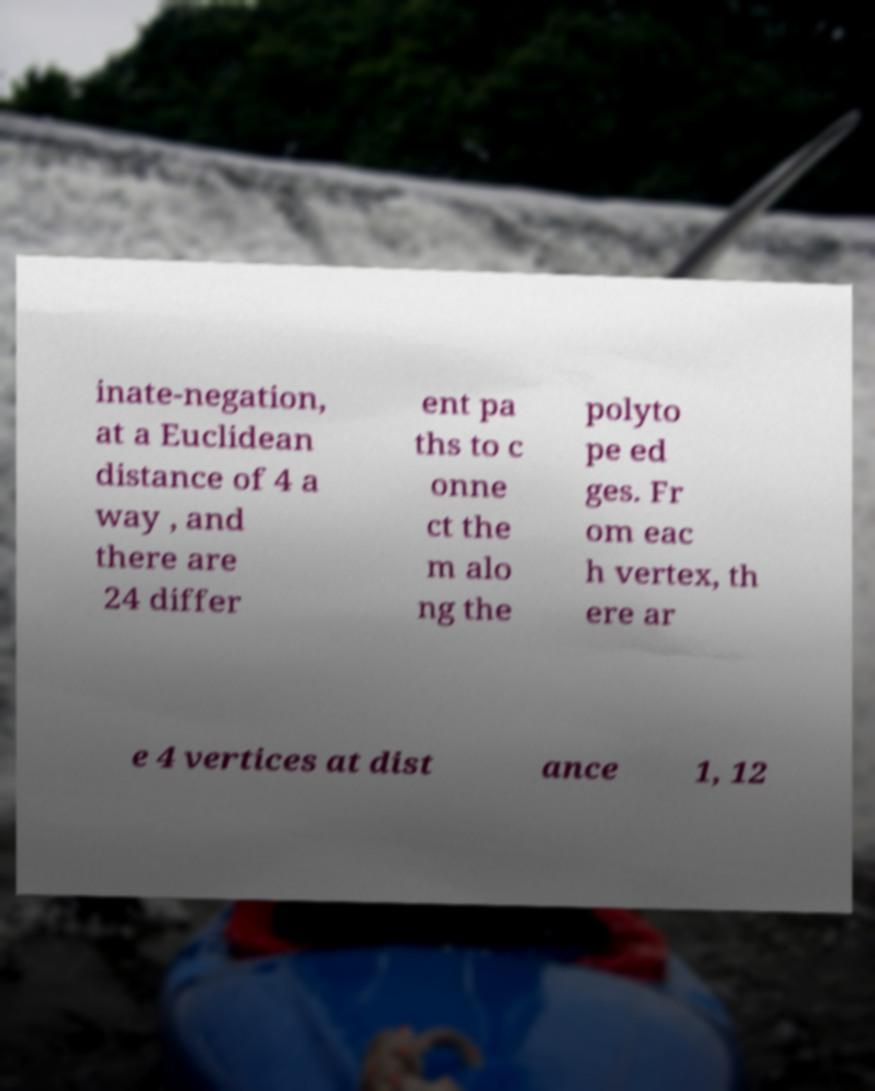I need the written content from this picture converted into text. Can you do that? inate-negation, at a Euclidean distance of 4 a way , and there are 24 differ ent pa ths to c onne ct the m alo ng the polyto pe ed ges. Fr om eac h vertex, th ere ar e 4 vertices at dist ance 1, 12 